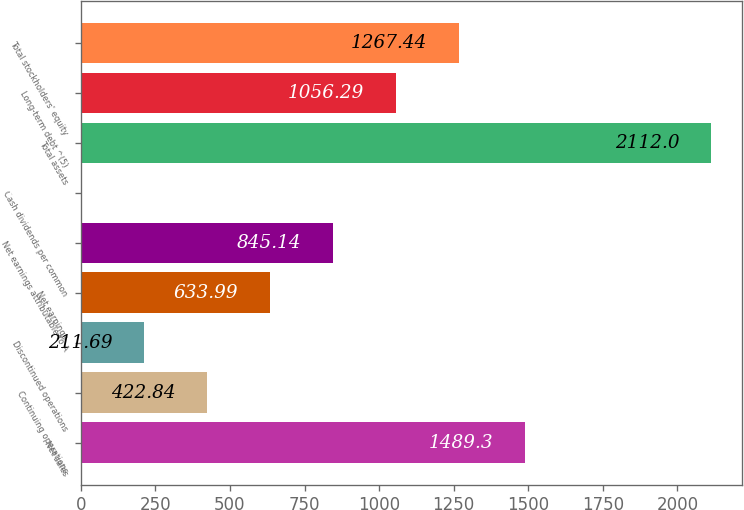Convert chart. <chart><loc_0><loc_0><loc_500><loc_500><bar_chart><fcel>Net sales<fcel>Continuing operations<fcel>Discontinued operations<fcel>Net earnings<fcel>Net earnings attributable to A<fcel>Cash dividends per common<fcel>Total assets<fcel>Long-term debt ^(5)<fcel>Total stockholders' equity<nl><fcel>1489.3<fcel>422.84<fcel>211.69<fcel>633.99<fcel>845.14<fcel>0.54<fcel>2112<fcel>1056.29<fcel>1267.44<nl></chart> 